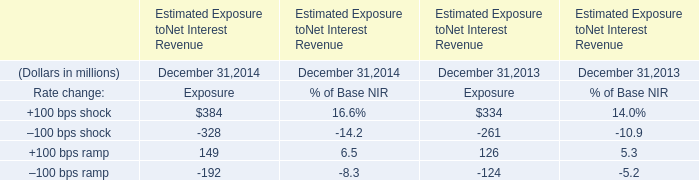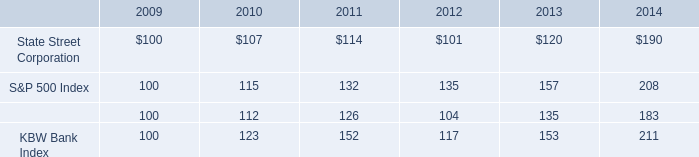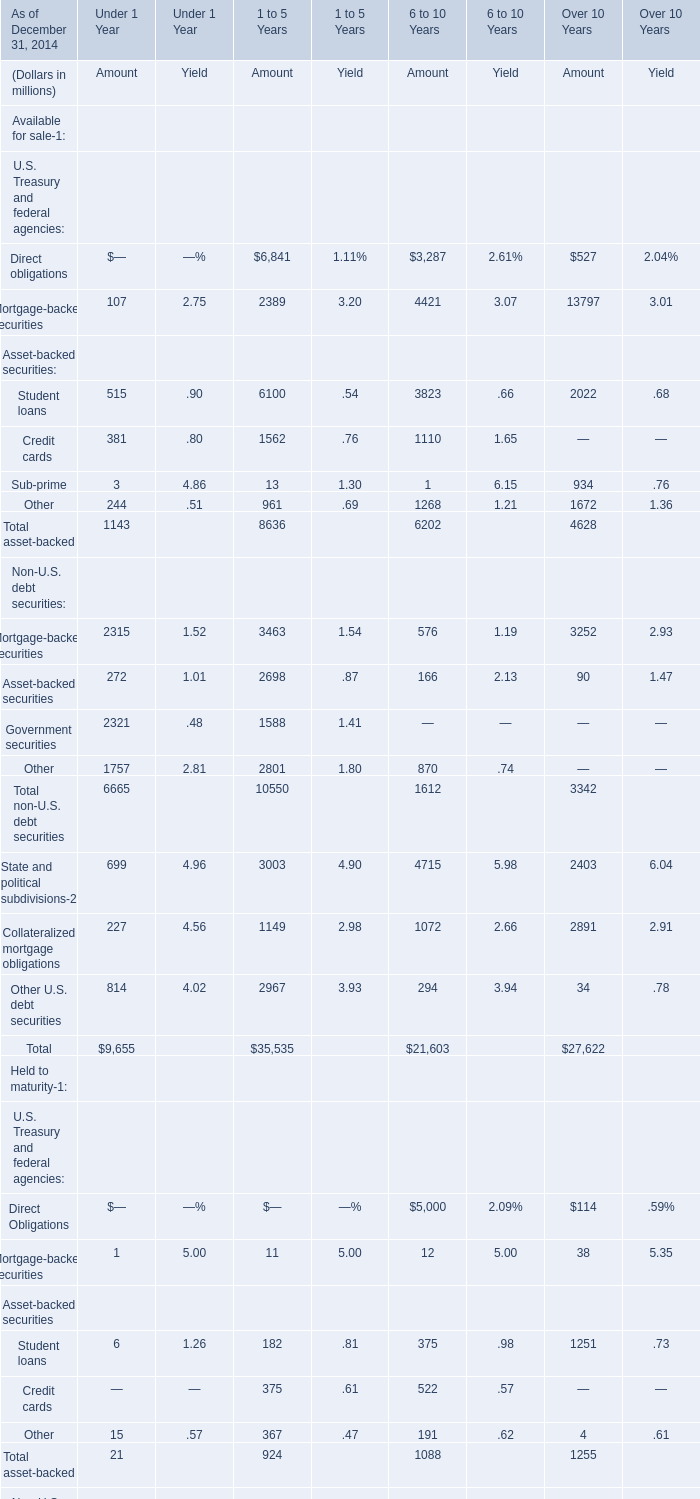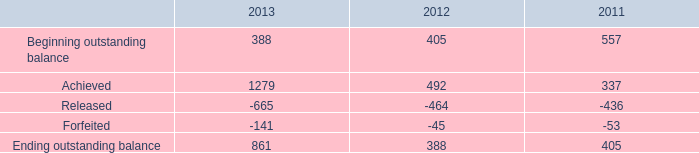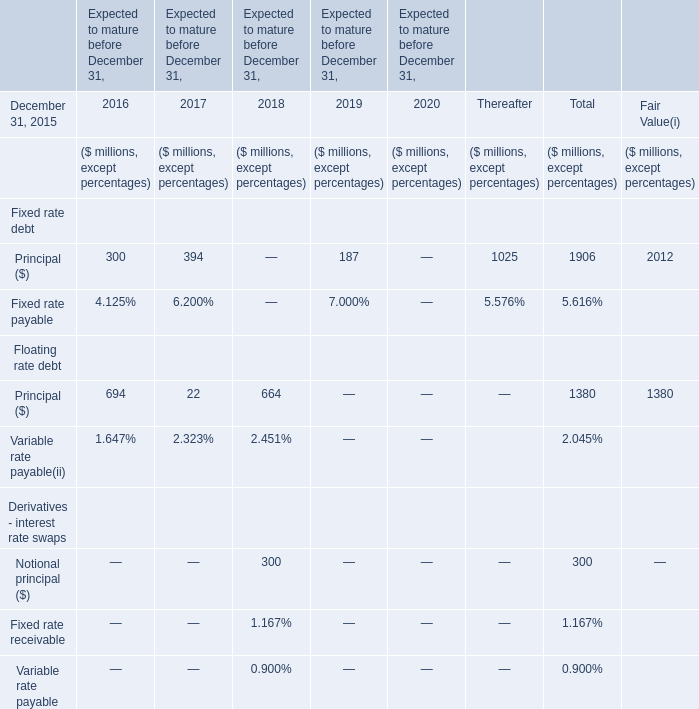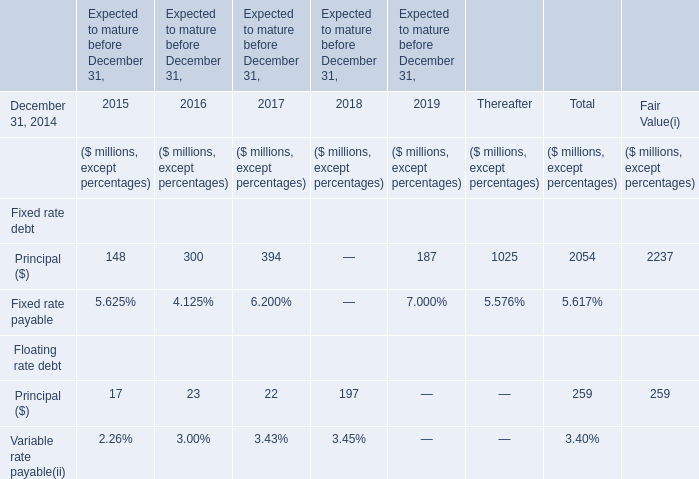In the section with largest amount of Student loans of Asset-backed securities, what's the sum of U.S. Treasury and federal agencies? (in million) 
Computations: (((182 + 11) + 375) + 367)
Answer: 935.0. 